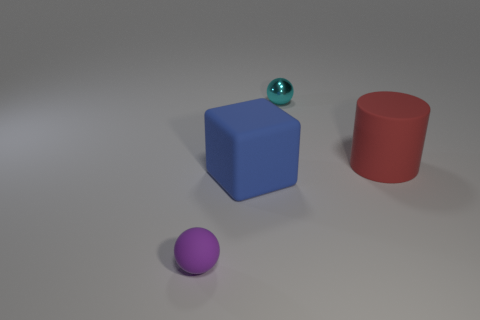Subtract all cubes. How many objects are left? 3 Add 4 brown matte objects. How many objects exist? 8 Subtract 1 red cylinders. How many objects are left? 3 Subtract all red cubes. Subtract all brown balls. How many cubes are left? 1 Subtract all small cyan spheres. Subtract all purple shiny spheres. How many objects are left? 3 Add 2 big objects. How many big objects are left? 4 Add 3 big blue blocks. How many big blue blocks exist? 4 